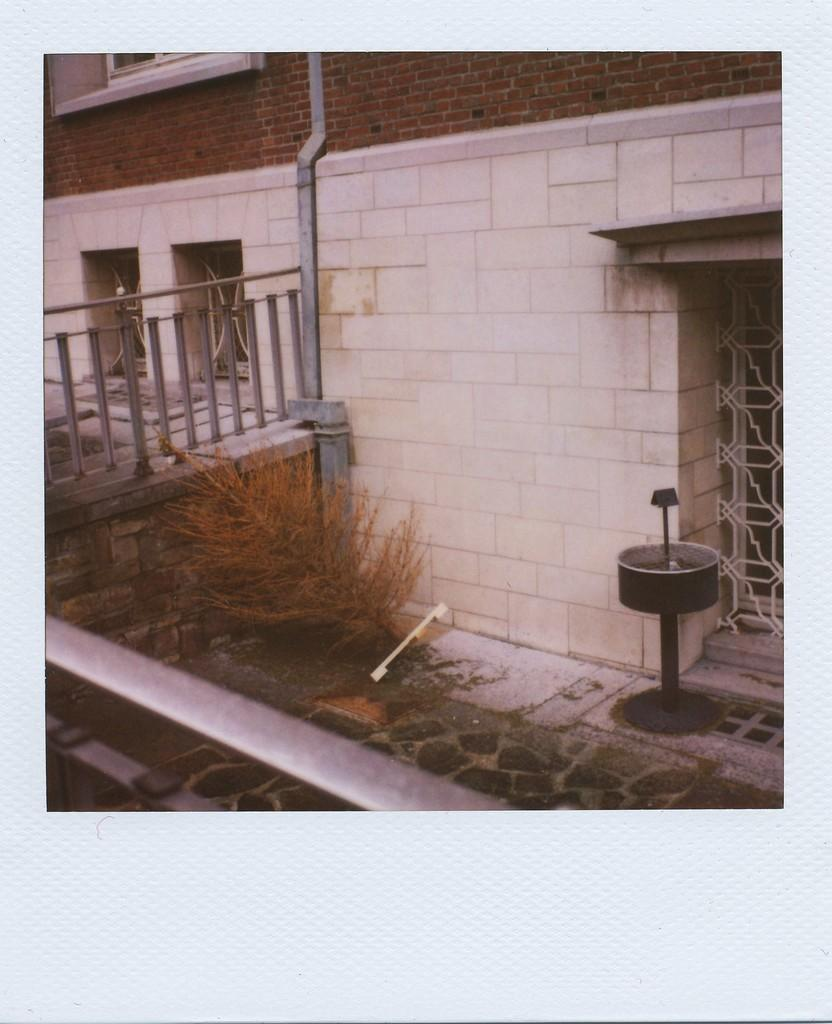What is the main subject of the image? There is a photograph of a building in the image. What else can be seen in the image besides the building? There is a fence and a plant in the image. What type of shirt is the plant wearing in the image? There is no shirt present in the image, as the subject is a plant. 